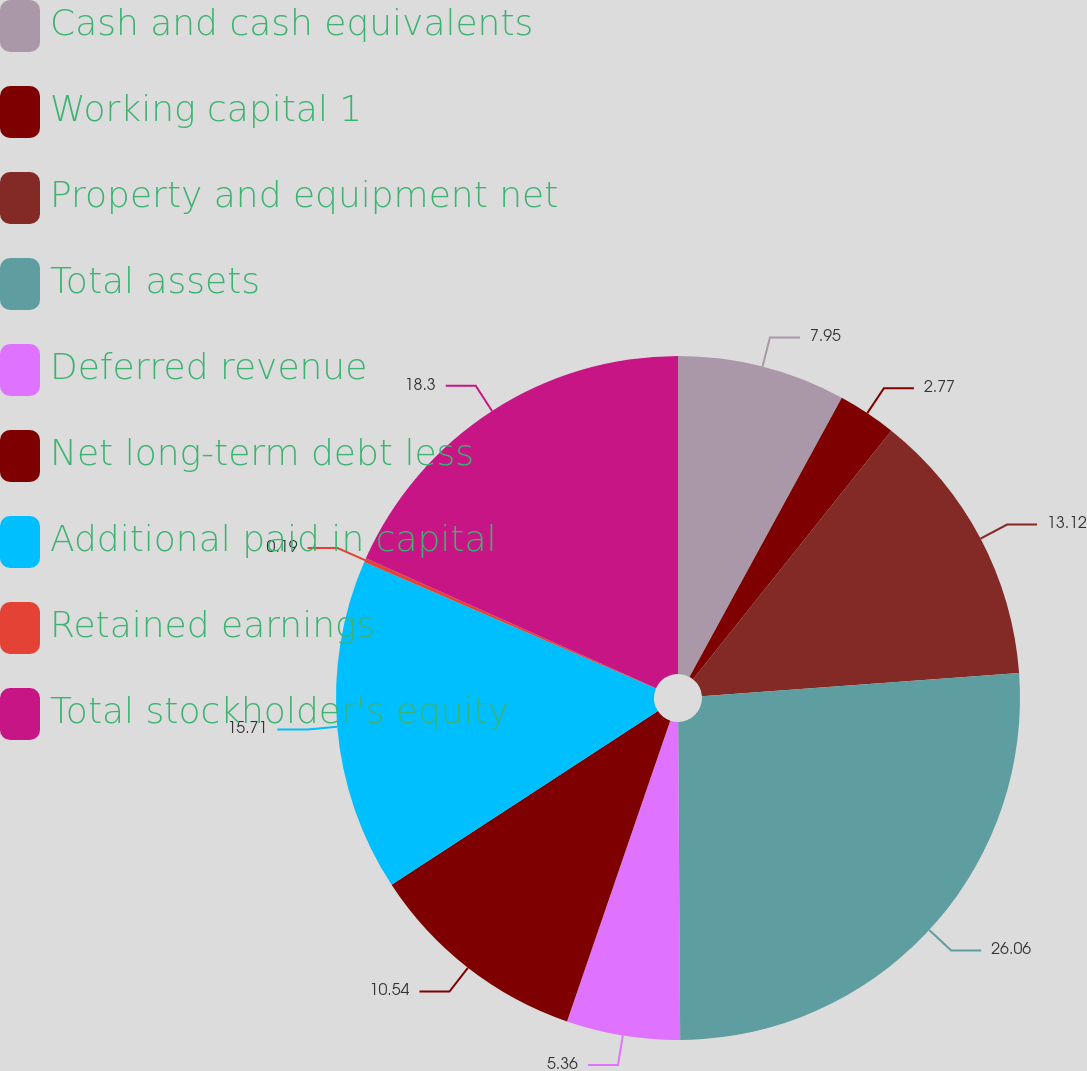Convert chart. <chart><loc_0><loc_0><loc_500><loc_500><pie_chart><fcel>Cash and cash equivalents<fcel>Working capital 1<fcel>Property and equipment net<fcel>Total assets<fcel>Deferred revenue<fcel>Net long-term debt less<fcel>Additional paid in capital<fcel>Retained earnings<fcel>Total stockholder's equity<nl><fcel>7.95%<fcel>2.77%<fcel>13.12%<fcel>26.06%<fcel>5.36%<fcel>10.54%<fcel>15.71%<fcel>0.19%<fcel>18.3%<nl></chart> 